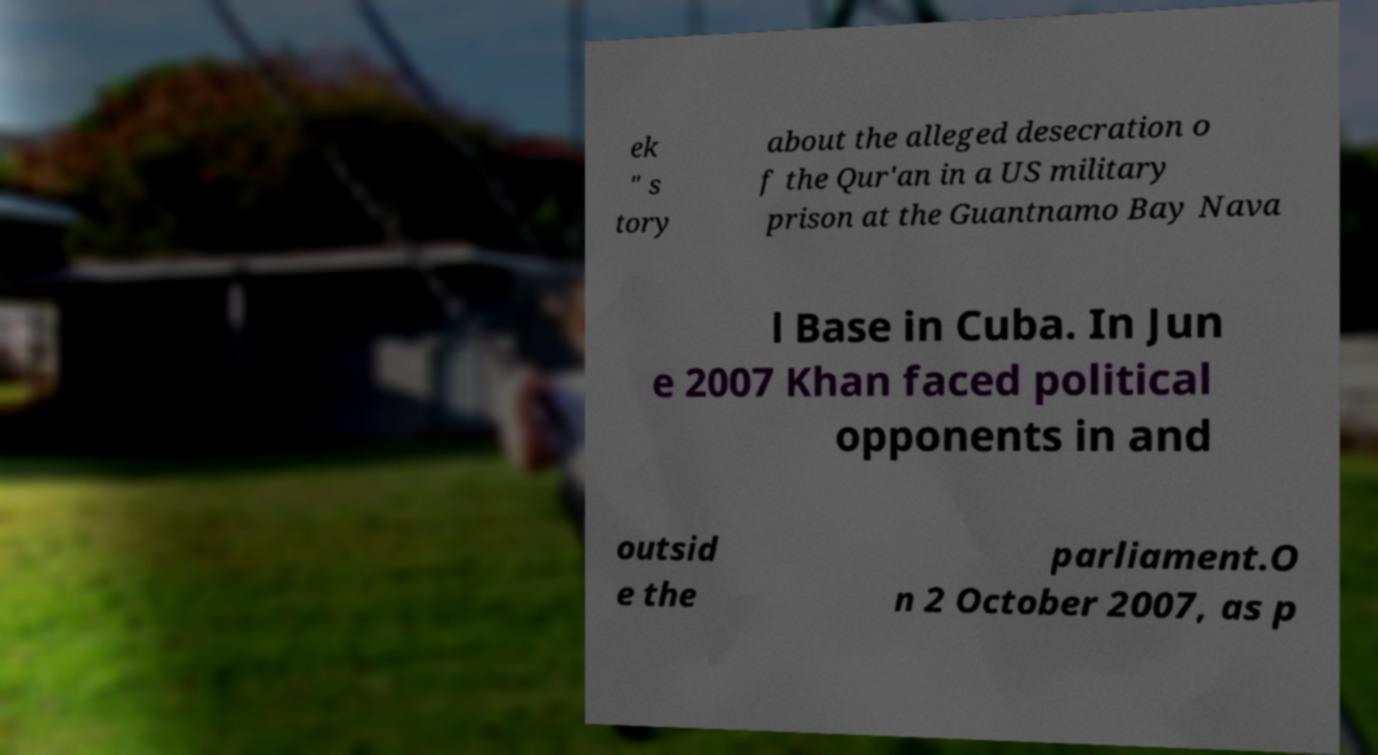Can you accurately transcribe the text from the provided image for me? ek " s tory about the alleged desecration o f the Qur'an in a US military prison at the Guantnamo Bay Nava l Base in Cuba. In Jun e 2007 Khan faced political opponents in and outsid e the parliament.O n 2 October 2007, as p 